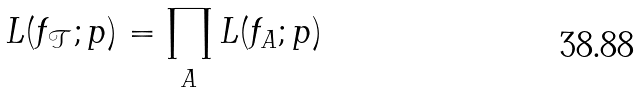Convert formula to latex. <formula><loc_0><loc_0><loc_500><loc_500>L ( f _ { \mathcal { T } } ; p ) = \prod _ { A } L ( f _ { A } ; p )</formula> 